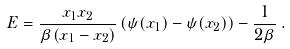Convert formula to latex. <formula><loc_0><loc_0><loc_500><loc_500>E = \frac { x _ { 1 } x _ { 2 } } { \beta ( x _ { 1 } - x _ { 2 } ) } \left ( \psi ( x _ { 1 } ) - \psi ( x _ { 2 } ) \right ) - \frac { 1 } { 2 \beta } \, .</formula> 